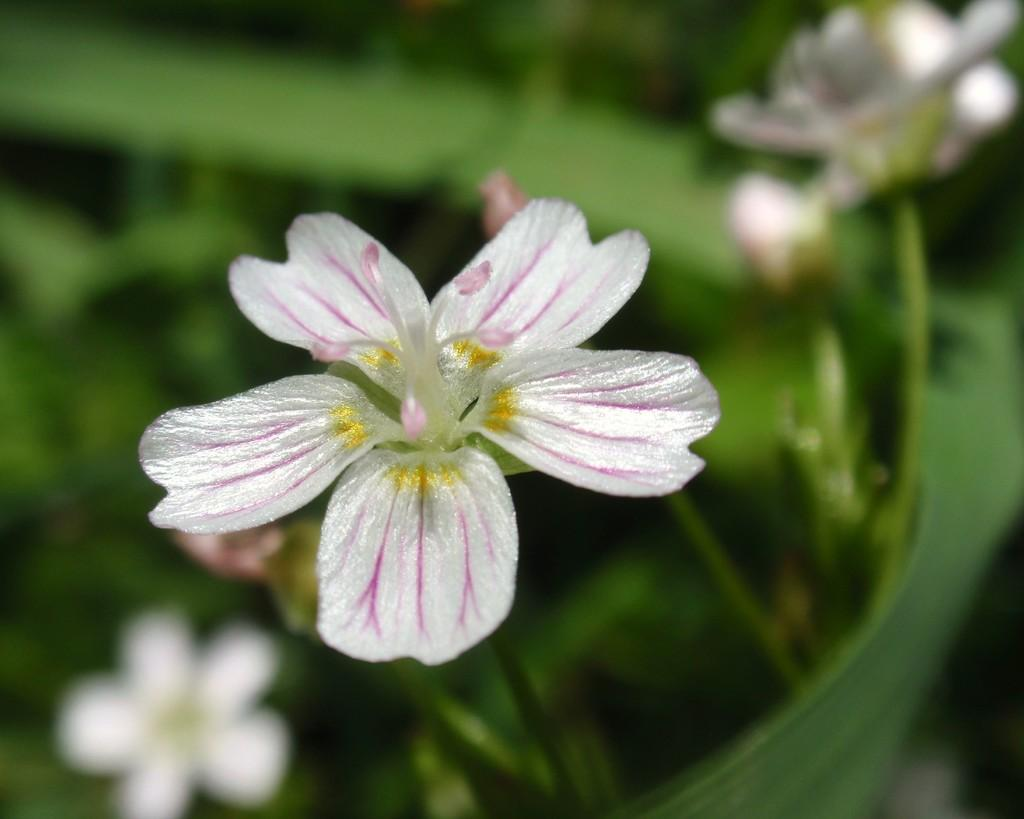What is the main subject of the image? There is a flower in the center of the image. What type of photography is used in the image? The image is a macro photography of the flower. How is the background of the image depicted? The background of the image is blurred. What type of quarter is depicted in the image? There is no quarter present in the image; it features a flower in macro photography with a blurred background. 